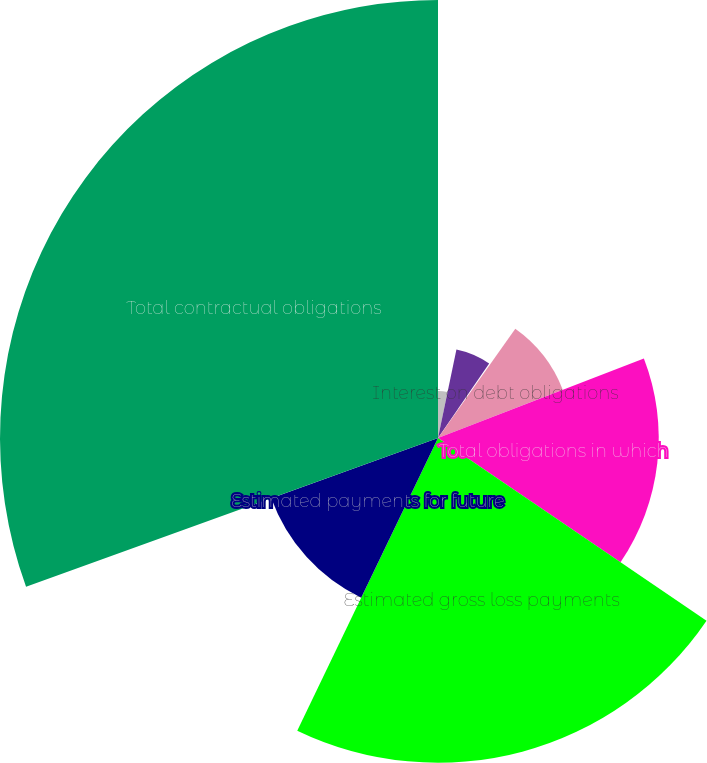<chart> <loc_0><loc_0><loc_500><loc_500><pie_chart><fcel>Deposit liabilities<fcel>Purchase obligations<fcel>Operating leases<fcel>Interest on debt obligations<fcel>Total obligations in which<fcel>Estimated gross loss payments<fcel>Estimated payments for future<fcel>Total contractual obligations<nl><fcel>3.27%<fcel>6.3%<fcel>0.24%<fcel>9.32%<fcel>15.38%<fcel>22.63%<fcel>12.35%<fcel>30.52%<nl></chart> 